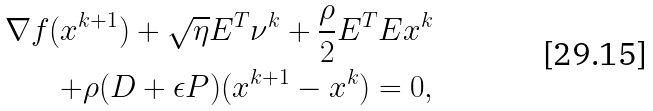Convert formula to latex. <formula><loc_0><loc_0><loc_500><loc_500>\nabla f ( x ^ { k + 1 } ) + \sqrt { \eta } E ^ { T } \nu ^ { k } + \frac { \rho } { 2 } E ^ { T } E x ^ { k } \\ + \rho ( D + \epsilon P ) ( x ^ { k + 1 } - x ^ { k } ) = 0 ,</formula> 